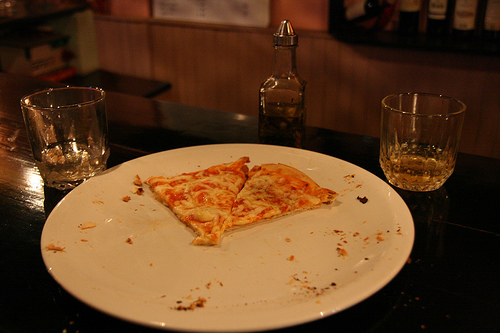Is the bench in the bottom part of the photo? No, there is no bench visible in the bottom part of the photo. The focus is solely on the tabletop with the pizza and drinks. 